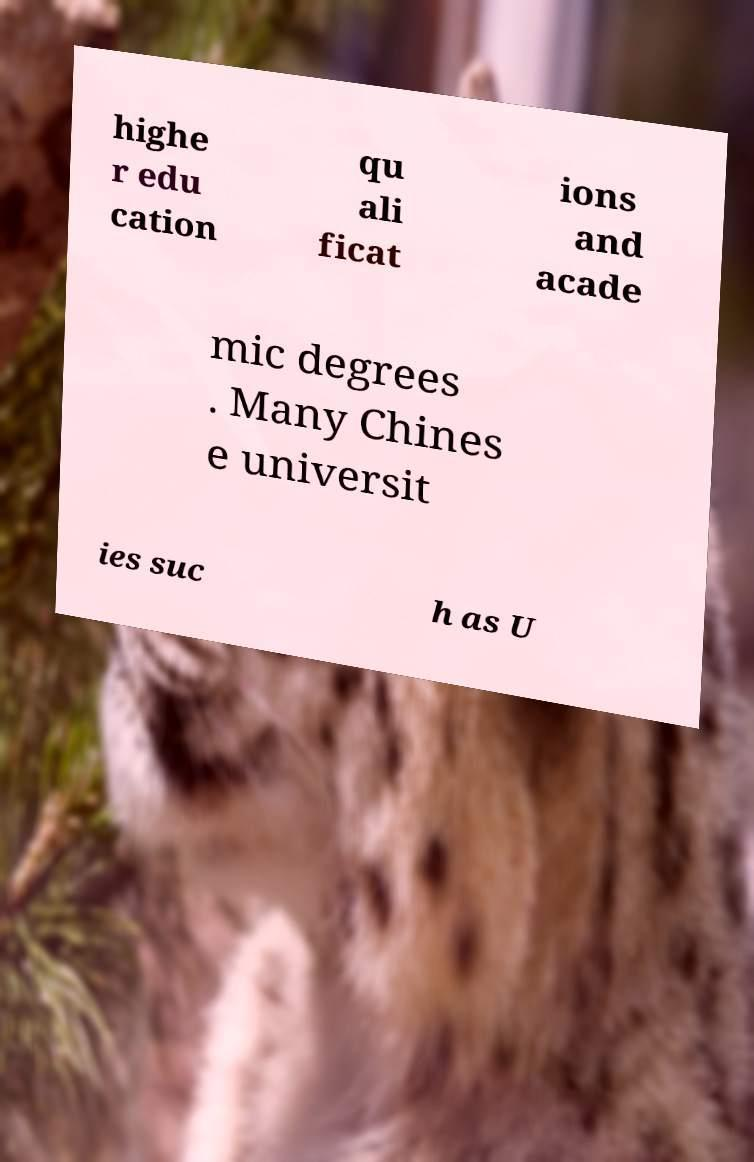For documentation purposes, I need the text within this image transcribed. Could you provide that? highe r edu cation qu ali ficat ions and acade mic degrees . Many Chines e universit ies suc h as U 